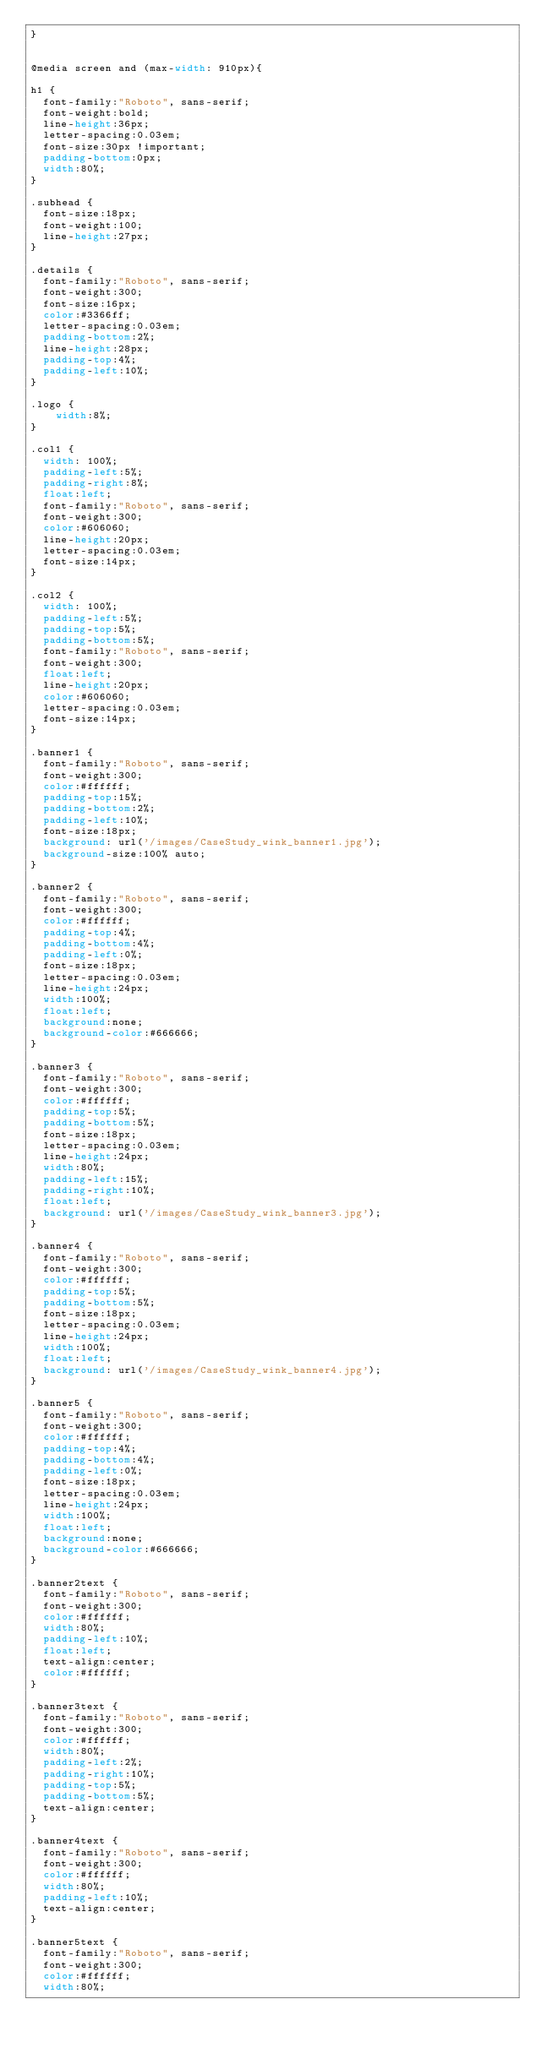Convert code to text. <code><loc_0><loc_0><loc_500><loc_500><_CSS_>}


@media screen and (max-width: 910px){

h1 {
  font-family:"Roboto", sans-serif;
  font-weight:bold;
  line-height:36px;
  letter-spacing:0.03em;
  font-size:30px !important;
  padding-bottom:0px;
  width:80%;
}

.subhead {
  font-size:18px;
  font-weight:100;
  line-height:27px;
}

.details {
  font-family:"Roboto", sans-serif;
  font-weight:300;
  font-size:16px;
  color:#3366ff;
  letter-spacing:0.03em;
  padding-bottom:2%;
  line-height:28px;
  padding-top:4%;
  padding-left:10%;
}

.logo {
    width:8%;
}

.col1 {
  width: 100%;
  padding-left:5%;
  padding-right:8%;
  float:left;
  font-family:"Roboto", sans-serif;
  font-weight:300;
  color:#606060;
  line-height:20px;
  letter-spacing:0.03em;
  font-size:14px;
}

.col2 {
  width: 100%;
  padding-left:5%;
  padding-top:5%;
  padding-bottom:5%;
  font-family:"Roboto", sans-serif;
  font-weight:300;
  float:left;
  line-height:20px;
  color:#606060;
  letter-spacing:0.03em;
  font-size:14px;
}

.banner1 {
  font-family:"Roboto", sans-serif;
  font-weight:300;
  color:#ffffff;
  padding-top:15%;
  padding-bottom:2%;
  padding-left:10%;
  font-size:18px;
  background: url('/images/CaseStudy_wink_banner1.jpg');
  background-size:100% auto;
}

.banner2 {
  font-family:"Roboto", sans-serif;
  font-weight:300;
  color:#ffffff;
  padding-top:4%;
  padding-bottom:4%;
  padding-left:0%;
  font-size:18px;
  letter-spacing:0.03em;
  line-height:24px;
  width:100%;
  float:left;
  background:none;
  background-color:#666666;
}

.banner3 {
  font-family:"Roboto", sans-serif;
  font-weight:300;
  color:#ffffff;
  padding-top:5%;
  padding-bottom:5%;
  font-size:18px;
  letter-spacing:0.03em;
  line-height:24px;
  width:80%;
  padding-left:15%;
  padding-right:10%;
  float:left;
  background: url('/images/CaseStudy_wink_banner3.jpg');
}

.banner4 {
  font-family:"Roboto", sans-serif;
  font-weight:300;
  color:#ffffff;
  padding-top:5%;
  padding-bottom:5%;
  font-size:18px;
  letter-spacing:0.03em;
  line-height:24px;
  width:100%;
  float:left;
  background: url('/images/CaseStudy_wink_banner4.jpg');
}

.banner5 {
  font-family:"Roboto", sans-serif;
  font-weight:300;
  color:#ffffff;
  padding-top:4%;
  padding-bottom:4%;
  padding-left:0%;
  font-size:18px;
  letter-spacing:0.03em;
  line-height:24px;
  width:100%;
  float:left;
  background:none;
  background-color:#666666;
}

.banner2text {
  font-family:"Roboto", sans-serif;
  font-weight:300;
  color:#ffffff;
  width:80%;
  padding-left:10%;
  float:left;
  text-align:center;
  color:#ffffff;
}

.banner3text {
  font-family:"Roboto", sans-serif;
  font-weight:300;
  color:#ffffff;
  width:80%;
  padding-left:2%;
  padding-right:10%;
  padding-top:5%;
  padding-bottom:5%;
  text-align:center;
}

.banner4text {
  font-family:"Roboto", sans-serif;
  font-weight:300;
  color:#ffffff;
  width:80%;
  padding-left:10%;
  text-align:center;
}

.banner5text {
  font-family:"Roboto", sans-serif;
  font-weight:300;
  color:#ffffff;
  width:80%;</code> 